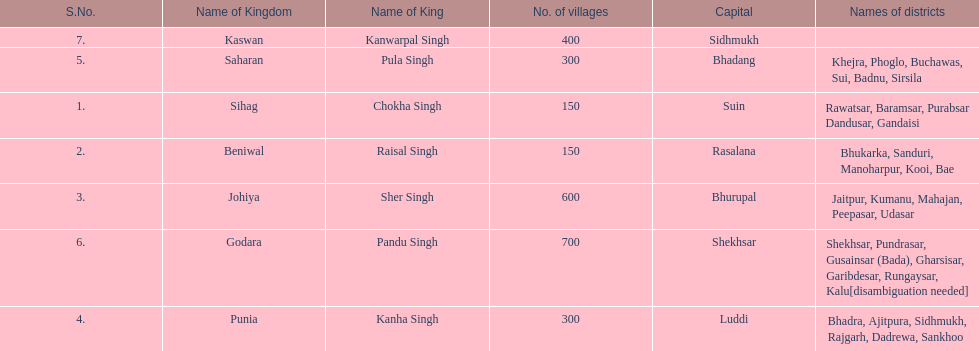How many kingdoms are listed? 7. 